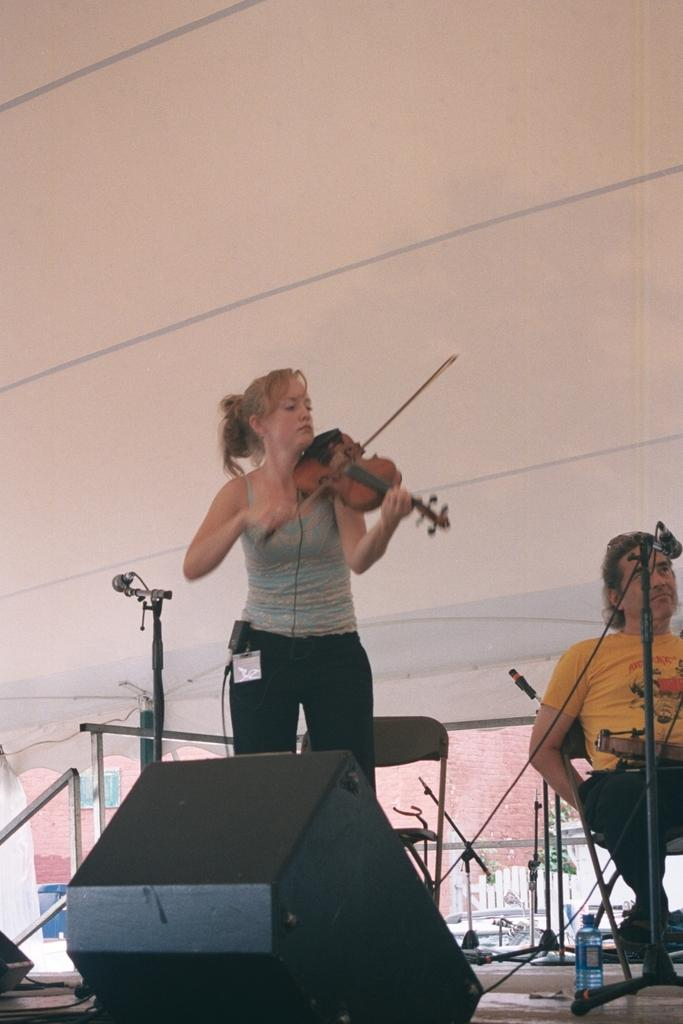What is the woman in the image doing? The woman is standing and playing a piano. What is the man in the image doing? The man is sitting on a chair. What object is in front of the man? There is a microphone in front of the man. Can you describe the background of the image? There is a chair and a wall in the background of the image. What type of insect can be seen crawling on the fog in the image? There is no fog or insect present in the image. What type of land is visible in the background of the image? The background of the image only shows a wall and a chair, so it is not possible to determine the type of land. 